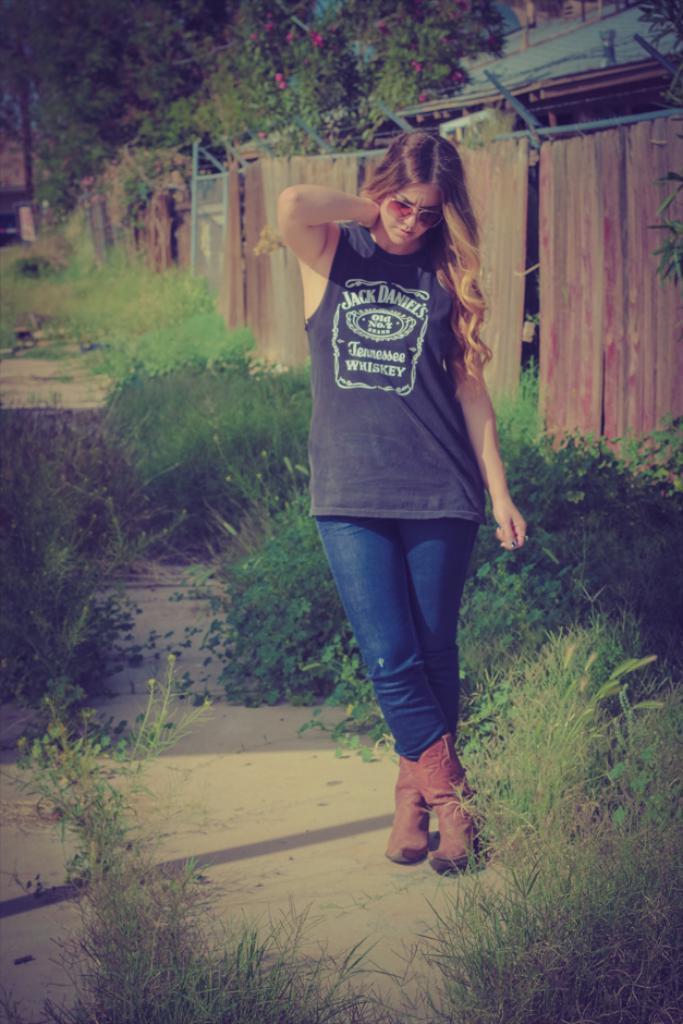In one or two sentences, can you explain what this image depicts? In this image there is a girl standing on the ground beside her there is a building, trees in front of a wooden fence. 